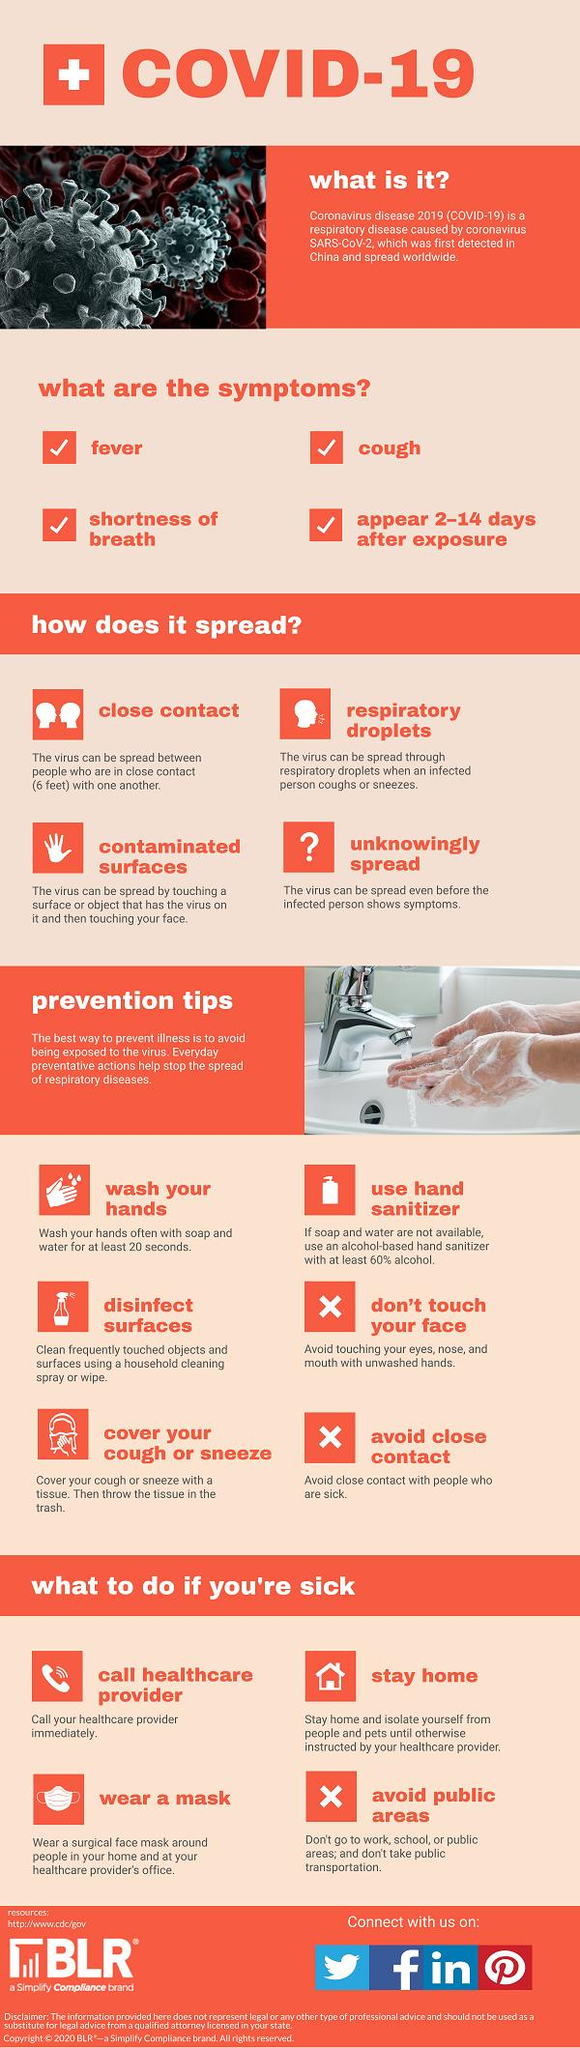Mention a couple of crucial points in this snapshot. It is recommended that individuals wash their hands for at least 20 seconds in order to effectively prevent the spread of COVID-19. The minimum safe distance to be maintained between oneself and others in order to control the spread of COVID-19 virus is six feet. The incubation period for COVID-19, the virus responsible for the ongoing pandemic, is typically between 2 and 14 days. During this time, an individual may be infected without showing any symptoms, and may unknowingly spread the virus to others. It is important to note that the exact duration of the incubation period can vary and may be influenced by factors such as age, overall health, and the severity of the virus. Hand sanitizer with at least 60% alcohol is recommended to effectively control the spread of COVID-19 virus. 